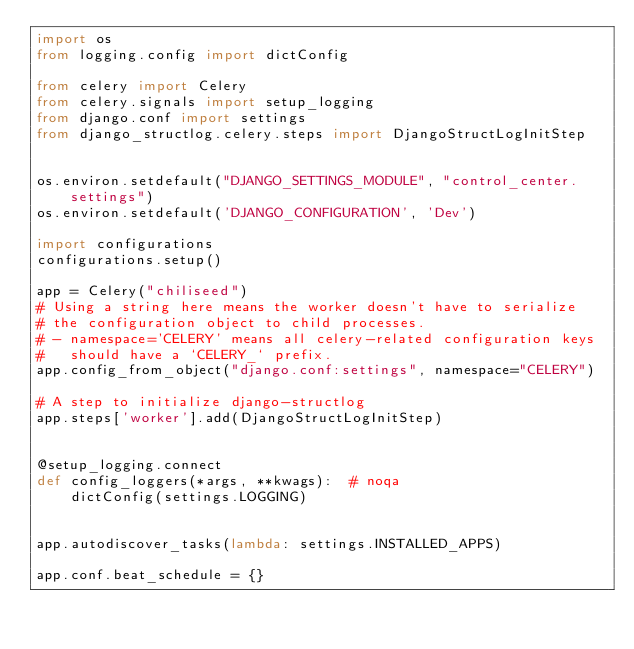Convert code to text. <code><loc_0><loc_0><loc_500><loc_500><_Python_>import os
from logging.config import dictConfig

from celery import Celery
from celery.signals import setup_logging
from django.conf import settings
from django_structlog.celery.steps import DjangoStructLogInitStep


os.environ.setdefault("DJANGO_SETTINGS_MODULE", "control_center.settings")
os.environ.setdefault('DJANGO_CONFIGURATION', 'Dev')

import configurations
configurations.setup()

app = Celery("chiliseed")
# Using a string here means the worker doesn't have to serialize
# the configuration object to child processes.
# - namespace='CELERY' means all celery-related configuration keys
#   should have a `CELERY_` prefix.
app.config_from_object("django.conf:settings", namespace="CELERY")

# A step to initialize django-structlog
app.steps['worker'].add(DjangoStructLogInitStep)


@setup_logging.connect
def config_loggers(*args, **kwags):  # noqa
    dictConfig(settings.LOGGING)


app.autodiscover_tasks(lambda: settings.INSTALLED_APPS)

app.conf.beat_schedule = {}
</code> 